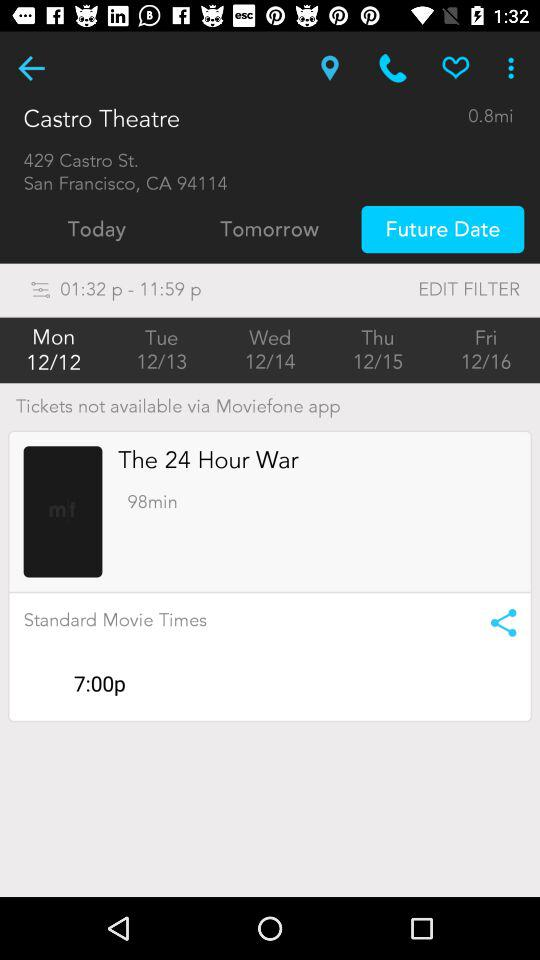How many days are available for tickets?
Answer the question using a single word or phrase. 5 